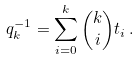<formula> <loc_0><loc_0><loc_500><loc_500>q _ { k } ^ { - 1 } = \sum _ { i = 0 } ^ { k } { k \choose i } t _ { i } \, .</formula> 